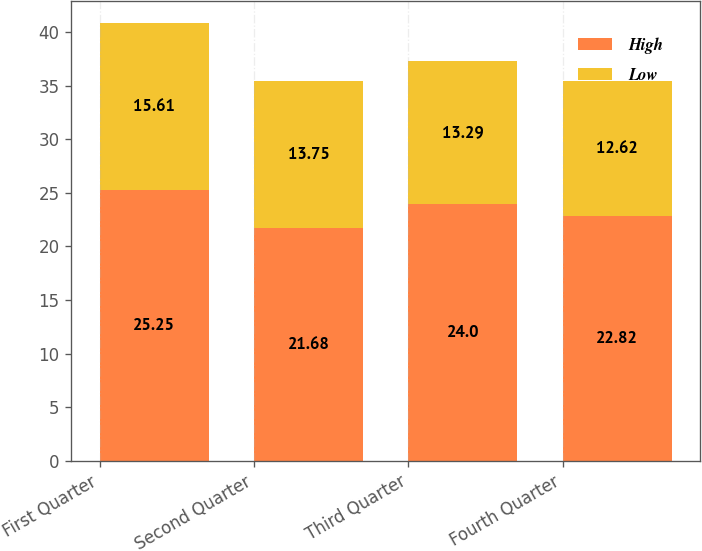Convert chart. <chart><loc_0><loc_0><loc_500><loc_500><stacked_bar_chart><ecel><fcel>First Quarter<fcel>Second Quarter<fcel>Third Quarter<fcel>Fourth Quarter<nl><fcel>High<fcel>25.25<fcel>21.68<fcel>24<fcel>22.82<nl><fcel>Low<fcel>15.61<fcel>13.75<fcel>13.29<fcel>12.62<nl></chart> 